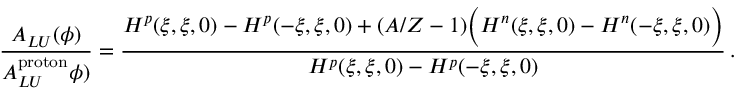Convert formula to latex. <formula><loc_0><loc_0><loc_500><loc_500>\frac { A _ { L U } ( \phi ) } { A _ { L U } ^ { p r o t o n } \phi ) } = \frac { H ^ { p } ( \xi , \xi , 0 ) - H ^ { p } ( - \xi , \xi , 0 ) + ( A / Z - 1 ) \left ( H ^ { n } ( \xi , \xi , 0 ) - H ^ { n } ( - \xi , \xi , 0 ) \right ) } { H ^ { p } ( \xi , \xi , 0 ) - H ^ { p } ( - \xi , \xi , 0 ) } \, .</formula> 